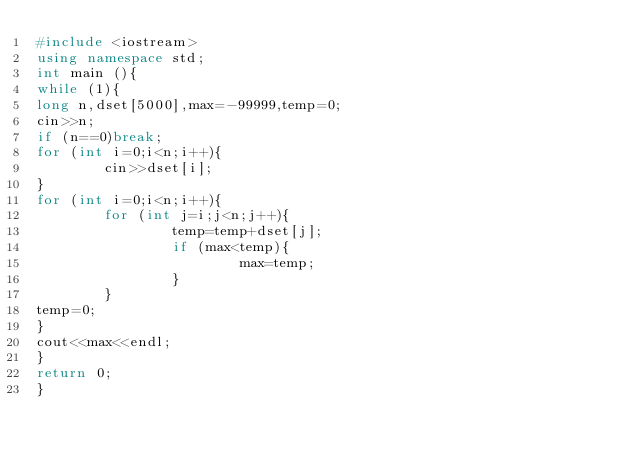<code> <loc_0><loc_0><loc_500><loc_500><_C++_>#include <iostream>
using namespace std;
int main (){
while (1){
long n,dset[5000],max=-99999,temp=0;
cin>>n;
if (n==0)break;
for (int i=0;i<n;i++){
        cin>>dset[i];
}
for (int i=0;i<n;i++){
        for (int j=i;j<n;j++){
                temp=temp+dset[j];
                if (max<temp){
                        max=temp;
                }
        }
temp=0;
}
cout<<max<<endl;
}
return 0;
}</code> 